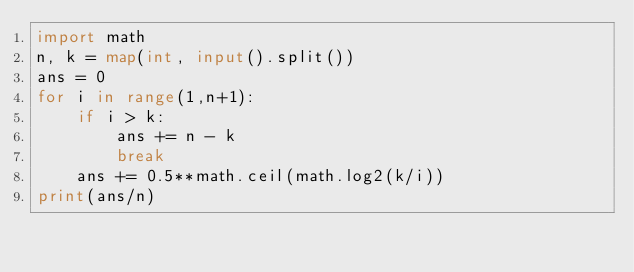<code> <loc_0><loc_0><loc_500><loc_500><_Python_>import math
n, k = map(int, input().split())
ans = 0
for i in range(1,n+1):
    if i > k:
        ans += n - k
        break
    ans += 0.5**math.ceil(math.log2(k/i))
print(ans/n)</code> 